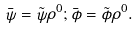Convert formula to latex. <formula><loc_0><loc_0><loc_500><loc_500>\bar { \psi } = \tilde { \psi } \rho ^ { 0 } ; \bar { \phi } = \tilde { \phi } \rho ^ { 0 } .</formula> 